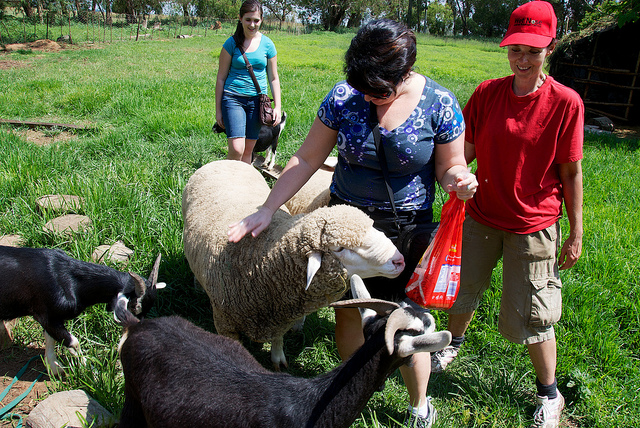Is there any object or thing in the image that might be out of place in a typical pasture or farm setting? The woman in the blue top is holding a red plastic bag, which is unusual in a farm or pasture setting. Typically, you would expect to see farming tools, feed containers, or natural items in such an environment. 